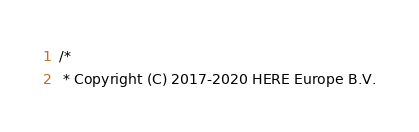<code> <loc_0><loc_0><loc_500><loc_500><_TypeScript_>/*
 * Copyright (C) 2017-2020 HERE Europe B.V.</code> 